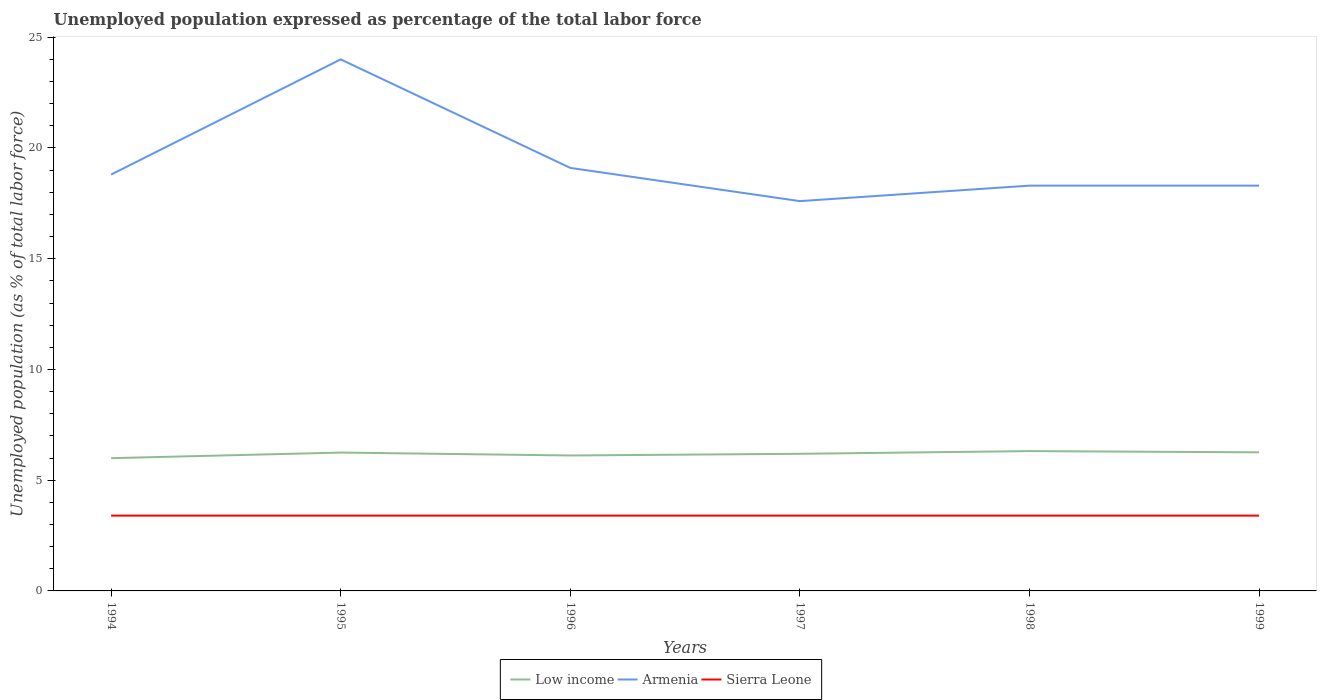Across all years, what is the maximum unemployment in in Low income?
Ensure brevity in your answer.  5.99. What is the difference between the highest and the lowest unemployment in in Armenia?
Provide a succinct answer. 1. How many years are there in the graph?
Provide a succinct answer. 6. Are the values on the major ticks of Y-axis written in scientific E-notation?
Your response must be concise. No. Does the graph contain grids?
Keep it short and to the point. No. Where does the legend appear in the graph?
Provide a short and direct response. Bottom center. How many legend labels are there?
Your answer should be very brief. 3. How are the legend labels stacked?
Offer a terse response. Horizontal. What is the title of the graph?
Offer a terse response. Unemployed population expressed as percentage of the total labor force. What is the label or title of the X-axis?
Provide a succinct answer. Years. What is the label or title of the Y-axis?
Your answer should be compact. Unemployed population (as % of total labor force). What is the Unemployed population (as % of total labor force) of Low income in 1994?
Make the answer very short. 5.99. What is the Unemployed population (as % of total labor force) in Armenia in 1994?
Provide a succinct answer. 18.8. What is the Unemployed population (as % of total labor force) of Sierra Leone in 1994?
Keep it short and to the point. 3.4. What is the Unemployed population (as % of total labor force) in Low income in 1995?
Make the answer very short. 6.25. What is the Unemployed population (as % of total labor force) of Armenia in 1995?
Your answer should be compact. 24. What is the Unemployed population (as % of total labor force) in Sierra Leone in 1995?
Provide a short and direct response. 3.4. What is the Unemployed population (as % of total labor force) of Low income in 1996?
Provide a short and direct response. 6.12. What is the Unemployed population (as % of total labor force) of Armenia in 1996?
Keep it short and to the point. 19.1. What is the Unemployed population (as % of total labor force) in Sierra Leone in 1996?
Ensure brevity in your answer.  3.4. What is the Unemployed population (as % of total labor force) in Low income in 1997?
Your answer should be compact. 6.19. What is the Unemployed population (as % of total labor force) of Armenia in 1997?
Make the answer very short. 17.6. What is the Unemployed population (as % of total labor force) of Sierra Leone in 1997?
Your answer should be very brief. 3.4. What is the Unemployed population (as % of total labor force) in Low income in 1998?
Offer a very short reply. 6.31. What is the Unemployed population (as % of total labor force) of Armenia in 1998?
Ensure brevity in your answer.  18.3. What is the Unemployed population (as % of total labor force) in Sierra Leone in 1998?
Make the answer very short. 3.4. What is the Unemployed population (as % of total labor force) of Low income in 1999?
Offer a terse response. 6.26. What is the Unemployed population (as % of total labor force) in Armenia in 1999?
Your answer should be compact. 18.3. What is the Unemployed population (as % of total labor force) in Sierra Leone in 1999?
Your answer should be very brief. 3.4. Across all years, what is the maximum Unemployed population (as % of total labor force) of Low income?
Make the answer very short. 6.31. Across all years, what is the maximum Unemployed population (as % of total labor force) of Armenia?
Offer a very short reply. 24. Across all years, what is the maximum Unemployed population (as % of total labor force) in Sierra Leone?
Your answer should be very brief. 3.4. Across all years, what is the minimum Unemployed population (as % of total labor force) of Low income?
Offer a terse response. 5.99. Across all years, what is the minimum Unemployed population (as % of total labor force) in Armenia?
Provide a succinct answer. 17.6. Across all years, what is the minimum Unemployed population (as % of total labor force) in Sierra Leone?
Ensure brevity in your answer.  3.4. What is the total Unemployed population (as % of total labor force) in Low income in the graph?
Offer a very short reply. 37.12. What is the total Unemployed population (as % of total labor force) in Armenia in the graph?
Keep it short and to the point. 116.1. What is the total Unemployed population (as % of total labor force) in Sierra Leone in the graph?
Provide a succinct answer. 20.4. What is the difference between the Unemployed population (as % of total labor force) of Low income in 1994 and that in 1995?
Keep it short and to the point. -0.25. What is the difference between the Unemployed population (as % of total labor force) in Low income in 1994 and that in 1996?
Provide a short and direct response. -0.12. What is the difference between the Unemployed population (as % of total labor force) in Low income in 1994 and that in 1997?
Offer a very short reply. -0.2. What is the difference between the Unemployed population (as % of total labor force) in Armenia in 1994 and that in 1997?
Give a very brief answer. 1.2. What is the difference between the Unemployed population (as % of total labor force) of Low income in 1994 and that in 1998?
Keep it short and to the point. -0.32. What is the difference between the Unemployed population (as % of total labor force) of Armenia in 1994 and that in 1998?
Give a very brief answer. 0.5. What is the difference between the Unemployed population (as % of total labor force) in Low income in 1994 and that in 1999?
Your response must be concise. -0.26. What is the difference between the Unemployed population (as % of total labor force) of Sierra Leone in 1994 and that in 1999?
Your answer should be compact. 0. What is the difference between the Unemployed population (as % of total labor force) of Low income in 1995 and that in 1996?
Ensure brevity in your answer.  0.13. What is the difference between the Unemployed population (as % of total labor force) of Low income in 1995 and that in 1997?
Ensure brevity in your answer.  0.06. What is the difference between the Unemployed population (as % of total labor force) in Low income in 1995 and that in 1998?
Provide a short and direct response. -0.07. What is the difference between the Unemployed population (as % of total labor force) in Sierra Leone in 1995 and that in 1998?
Give a very brief answer. 0. What is the difference between the Unemployed population (as % of total labor force) in Low income in 1995 and that in 1999?
Your response must be concise. -0.01. What is the difference between the Unemployed population (as % of total labor force) in Sierra Leone in 1995 and that in 1999?
Your answer should be very brief. 0. What is the difference between the Unemployed population (as % of total labor force) in Low income in 1996 and that in 1997?
Make the answer very short. -0.08. What is the difference between the Unemployed population (as % of total labor force) of Sierra Leone in 1996 and that in 1997?
Make the answer very short. 0. What is the difference between the Unemployed population (as % of total labor force) of Low income in 1996 and that in 1998?
Give a very brief answer. -0.2. What is the difference between the Unemployed population (as % of total labor force) in Armenia in 1996 and that in 1998?
Your answer should be compact. 0.8. What is the difference between the Unemployed population (as % of total labor force) of Low income in 1996 and that in 1999?
Give a very brief answer. -0.14. What is the difference between the Unemployed population (as % of total labor force) in Sierra Leone in 1996 and that in 1999?
Provide a short and direct response. 0. What is the difference between the Unemployed population (as % of total labor force) of Low income in 1997 and that in 1998?
Offer a terse response. -0.12. What is the difference between the Unemployed population (as % of total labor force) in Armenia in 1997 and that in 1998?
Your answer should be compact. -0.7. What is the difference between the Unemployed population (as % of total labor force) in Sierra Leone in 1997 and that in 1998?
Provide a short and direct response. 0. What is the difference between the Unemployed population (as % of total labor force) of Low income in 1997 and that in 1999?
Provide a succinct answer. -0.07. What is the difference between the Unemployed population (as % of total labor force) of Armenia in 1997 and that in 1999?
Provide a succinct answer. -0.7. What is the difference between the Unemployed population (as % of total labor force) of Low income in 1998 and that in 1999?
Offer a terse response. 0.06. What is the difference between the Unemployed population (as % of total labor force) in Low income in 1994 and the Unemployed population (as % of total labor force) in Armenia in 1995?
Offer a very short reply. -18.01. What is the difference between the Unemployed population (as % of total labor force) in Low income in 1994 and the Unemployed population (as % of total labor force) in Sierra Leone in 1995?
Provide a short and direct response. 2.59. What is the difference between the Unemployed population (as % of total labor force) of Armenia in 1994 and the Unemployed population (as % of total labor force) of Sierra Leone in 1995?
Offer a very short reply. 15.4. What is the difference between the Unemployed population (as % of total labor force) in Low income in 1994 and the Unemployed population (as % of total labor force) in Armenia in 1996?
Ensure brevity in your answer.  -13.11. What is the difference between the Unemployed population (as % of total labor force) of Low income in 1994 and the Unemployed population (as % of total labor force) of Sierra Leone in 1996?
Provide a succinct answer. 2.59. What is the difference between the Unemployed population (as % of total labor force) in Low income in 1994 and the Unemployed population (as % of total labor force) in Armenia in 1997?
Your answer should be compact. -11.61. What is the difference between the Unemployed population (as % of total labor force) of Low income in 1994 and the Unemployed population (as % of total labor force) of Sierra Leone in 1997?
Make the answer very short. 2.59. What is the difference between the Unemployed population (as % of total labor force) of Armenia in 1994 and the Unemployed population (as % of total labor force) of Sierra Leone in 1997?
Offer a very short reply. 15.4. What is the difference between the Unemployed population (as % of total labor force) of Low income in 1994 and the Unemployed population (as % of total labor force) of Armenia in 1998?
Offer a terse response. -12.31. What is the difference between the Unemployed population (as % of total labor force) in Low income in 1994 and the Unemployed population (as % of total labor force) in Sierra Leone in 1998?
Your response must be concise. 2.59. What is the difference between the Unemployed population (as % of total labor force) in Armenia in 1994 and the Unemployed population (as % of total labor force) in Sierra Leone in 1998?
Offer a very short reply. 15.4. What is the difference between the Unemployed population (as % of total labor force) in Low income in 1994 and the Unemployed population (as % of total labor force) in Armenia in 1999?
Your answer should be compact. -12.31. What is the difference between the Unemployed population (as % of total labor force) in Low income in 1994 and the Unemployed population (as % of total labor force) in Sierra Leone in 1999?
Offer a terse response. 2.59. What is the difference between the Unemployed population (as % of total labor force) in Armenia in 1994 and the Unemployed population (as % of total labor force) in Sierra Leone in 1999?
Ensure brevity in your answer.  15.4. What is the difference between the Unemployed population (as % of total labor force) in Low income in 1995 and the Unemployed population (as % of total labor force) in Armenia in 1996?
Offer a very short reply. -12.85. What is the difference between the Unemployed population (as % of total labor force) in Low income in 1995 and the Unemployed population (as % of total labor force) in Sierra Leone in 1996?
Make the answer very short. 2.85. What is the difference between the Unemployed population (as % of total labor force) of Armenia in 1995 and the Unemployed population (as % of total labor force) of Sierra Leone in 1996?
Provide a short and direct response. 20.6. What is the difference between the Unemployed population (as % of total labor force) in Low income in 1995 and the Unemployed population (as % of total labor force) in Armenia in 1997?
Keep it short and to the point. -11.35. What is the difference between the Unemployed population (as % of total labor force) of Low income in 1995 and the Unemployed population (as % of total labor force) of Sierra Leone in 1997?
Provide a succinct answer. 2.85. What is the difference between the Unemployed population (as % of total labor force) in Armenia in 1995 and the Unemployed population (as % of total labor force) in Sierra Leone in 1997?
Offer a very short reply. 20.6. What is the difference between the Unemployed population (as % of total labor force) in Low income in 1995 and the Unemployed population (as % of total labor force) in Armenia in 1998?
Offer a terse response. -12.05. What is the difference between the Unemployed population (as % of total labor force) in Low income in 1995 and the Unemployed population (as % of total labor force) in Sierra Leone in 1998?
Make the answer very short. 2.85. What is the difference between the Unemployed population (as % of total labor force) of Armenia in 1995 and the Unemployed population (as % of total labor force) of Sierra Leone in 1998?
Your response must be concise. 20.6. What is the difference between the Unemployed population (as % of total labor force) in Low income in 1995 and the Unemployed population (as % of total labor force) in Armenia in 1999?
Keep it short and to the point. -12.05. What is the difference between the Unemployed population (as % of total labor force) of Low income in 1995 and the Unemployed population (as % of total labor force) of Sierra Leone in 1999?
Make the answer very short. 2.85. What is the difference between the Unemployed population (as % of total labor force) of Armenia in 1995 and the Unemployed population (as % of total labor force) of Sierra Leone in 1999?
Provide a short and direct response. 20.6. What is the difference between the Unemployed population (as % of total labor force) in Low income in 1996 and the Unemployed population (as % of total labor force) in Armenia in 1997?
Ensure brevity in your answer.  -11.48. What is the difference between the Unemployed population (as % of total labor force) of Low income in 1996 and the Unemployed population (as % of total labor force) of Sierra Leone in 1997?
Make the answer very short. 2.72. What is the difference between the Unemployed population (as % of total labor force) of Low income in 1996 and the Unemployed population (as % of total labor force) of Armenia in 1998?
Offer a very short reply. -12.18. What is the difference between the Unemployed population (as % of total labor force) of Low income in 1996 and the Unemployed population (as % of total labor force) of Sierra Leone in 1998?
Provide a short and direct response. 2.72. What is the difference between the Unemployed population (as % of total labor force) in Low income in 1996 and the Unemployed population (as % of total labor force) in Armenia in 1999?
Offer a very short reply. -12.18. What is the difference between the Unemployed population (as % of total labor force) of Low income in 1996 and the Unemployed population (as % of total labor force) of Sierra Leone in 1999?
Make the answer very short. 2.72. What is the difference between the Unemployed population (as % of total labor force) in Armenia in 1996 and the Unemployed population (as % of total labor force) in Sierra Leone in 1999?
Your response must be concise. 15.7. What is the difference between the Unemployed population (as % of total labor force) of Low income in 1997 and the Unemployed population (as % of total labor force) of Armenia in 1998?
Offer a terse response. -12.11. What is the difference between the Unemployed population (as % of total labor force) of Low income in 1997 and the Unemployed population (as % of total labor force) of Sierra Leone in 1998?
Give a very brief answer. 2.79. What is the difference between the Unemployed population (as % of total labor force) in Armenia in 1997 and the Unemployed population (as % of total labor force) in Sierra Leone in 1998?
Ensure brevity in your answer.  14.2. What is the difference between the Unemployed population (as % of total labor force) of Low income in 1997 and the Unemployed population (as % of total labor force) of Armenia in 1999?
Your answer should be compact. -12.11. What is the difference between the Unemployed population (as % of total labor force) in Low income in 1997 and the Unemployed population (as % of total labor force) in Sierra Leone in 1999?
Provide a succinct answer. 2.79. What is the difference between the Unemployed population (as % of total labor force) in Armenia in 1997 and the Unemployed population (as % of total labor force) in Sierra Leone in 1999?
Keep it short and to the point. 14.2. What is the difference between the Unemployed population (as % of total labor force) in Low income in 1998 and the Unemployed population (as % of total labor force) in Armenia in 1999?
Offer a very short reply. -11.99. What is the difference between the Unemployed population (as % of total labor force) of Low income in 1998 and the Unemployed population (as % of total labor force) of Sierra Leone in 1999?
Provide a succinct answer. 2.91. What is the difference between the Unemployed population (as % of total labor force) of Armenia in 1998 and the Unemployed population (as % of total labor force) of Sierra Leone in 1999?
Offer a terse response. 14.9. What is the average Unemployed population (as % of total labor force) in Low income per year?
Offer a very short reply. 6.19. What is the average Unemployed population (as % of total labor force) in Armenia per year?
Keep it short and to the point. 19.35. What is the average Unemployed population (as % of total labor force) of Sierra Leone per year?
Provide a short and direct response. 3.4. In the year 1994, what is the difference between the Unemployed population (as % of total labor force) in Low income and Unemployed population (as % of total labor force) in Armenia?
Your response must be concise. -12.81. In the year 1994, what is the difference between the Unemployed population (as % of total labor force) of Low income and Unemployed population (as % of total labor force) of Sierra Leone?
Your response must be concise. 2.59. In the year 1995, what is the difference between the Unemployed population (as % of total labor force) in Low income and Unemployed population (as % of total labor force) in Armenia?
Keep it short and to the point. -17.75. In the year 1995, what is the difference between the Unemployed population (as % of total labor force) in Low income and Unemployed population (as % of total labor force) in Sierra Leone?
Offer a very short reply. 2.85. In the year 1995, what is the difference between the Unemployed population (as % of total labor force) in Armenia and Unemployed population (as % of total labor force) in Sierra Leone?
Your answer should be very brief. 20.6. In the year 1996, what is the difference between the Unemployed population (as % of total labor force) of Low income and Unemployed population (as % of total labor force) of Armenia?
Keep it short and to the point. -12.98. In the year 1996, what is the difference between the Unemployed population (as % of total labor force) of Low income and Unemployed population (as % of total labor force) of Sierra Leone?
Offer a terse response. 2.72. In the year 1997, what is the difference between the Unemployed population (as % of total labor force) in Low income and Unemployed population (as % of total labor force) in Armenia?
Keep it short and to the point. -11.41. In the year 1997, what is the difference between the Unemployed population (as % of total labor force) of Low income and Unemployed population (as % of total labor force) of Sierra Leone?
Ensure brevity in your answer.  2.79. In the year 1997, what is the difference between the Unemployed population (as % of total labor force) in Armenia and Unemployed population (as % of total labor force) in Sierra Leone?
Ensure brevity in your answer.  14.2. In the year 1998, what is the difference between the Unemployed population (as % of total labor force) of Low income and Unemployed population (as % of total labor force) of Armenia?
Your answer should be compact. -11.99. In the year 1998, what is the difference between the Unemployed population (as % of total labor force) of Low income and Unemployed population (as % of total labor force) of Sierra Leone?
Your answer should be compact. 2.91. In the year 1998, what is the difference between the Unemployed population (as % of total labor force) of Armenia and Unemployed population (as % of total labor force) of Sierra Leone?
Your answer should be compact. 14.9. In the year 1999, what is the difference between the Unemployed population (as % of total labor force) of Low income and Unemployed population (as % of total labor force) of Armenia?
Your response must be concise. -12.04. In the year 1999, what is the difference between the Unemployed population (as % of total labor force) in Low income and Unemployed population (as % of total labor force) in Sierra Leone?
Your answer should be very brief. 2.86. In the year 1999, what is the difference between the Unemployed population (as % of total labor force) of Armenia and Unemployed population (as % of total labor force) of Sierra Leone?
Your response must be concise. 14.9. What is the ratio of the Unemployed population (as % of total labor force) in Low income in 1994 to that in 1995?
Keep it short and to the point. 0.96. What is the ratio of the Unemployed population (as % of total labor force) of Armenia in 1994 to that in 1995?
Give a very brief answer. 0.78. What is the ratio of the Unemployed population (as % of total labor force) in Sierra Leone in 1994 to that in 1995?
Your response must be concise. 1. What is the ratio of the Unemployed population (as % of total labor force) of Low income in 1994 to that in 1996?
Ensure brevity in your answer.  0.98. What is the ratio of the Unemployed population (as % of total labor force) of Armenia in 1994 to that in 1996?
Keep it short and to the point. 0.98. What is the ratio of the Unemployed population (as % of total labor force) of Low income in 1994 to that in 1997?
Provide a succinct answer. 0.97. What is the ratio of the Unemployed population (as % of total labor force) of Armenia in 1994 to that in 1997?
Offer a terse response. 1.07. What is the ratio of the Unemployed population (as % of total labor force) in Low income in 1994 to that in 1998?
Provide a succinct answer. 0.95. What is the ratio of the Unemployed population (as % of total labor force) in Armenia in 1994 to that in 1998?
Offer a very short reply. 1.03. What is the ratio of the Unemployed population (as % of total labor force) in Sierra Leone in 1994 to that in 1998?
Your answer should be very brief. 1. What is the ratio of the Unemployed population (as % of total labor force) of Low income in 1994 to that in 1999?
Give a very brief answer. 0.96. What is the ratio of the Unemployed population (as % of total labor force) in Armenia in 1994 to that in 1999?
Your answer should be compact. 1.03. What is the ratio of the Unemployed population (as % of total labor force) in Sierra Leone in 1994 to that in 1999?
Provide a short and direct response. 1. What is the ratio of the Unemployed population (as % of total labor force) in Low income in 1995 to that in 1996?
Ensure brevity in your answer.  1.02. What is the ratio of the Unemployed population (as % of total labor force) of Armenia in 1995 to that in 1996?
Ensure brevity in your answer.  1.26. What is the ratio of the Unemployed population (as % of total labor force) of Sierra Leone in 1995 to that in 1996?
Provide a short and direct response. 1. What is the ratio of the Unemployed population (as % of total labor force) in Low income in 1995 to that in 1997?
Keep it short and to the point. 1.01. What is the ratio of the Unemployed population (as % of total labor force) in Armenia in 1995 to that in 1997?
Offer a terse response. 1.36. What is the ratio of the Unemployed population (as % of total labor force) in Armenia in 1995 to that in 1998?
Offer a very short reply. 1.31. What is the ratio of the Unemployed population (as % of total labor force) of Low income in 1995 to that in 1999?
Your response must be concise. 1. What is the ratio of the Unemployed population (as % of total labor force) of Armenia in 1995 to that in 1999?
Make the answer very short. 1.31. What is the ratio of the Unemployed population (as % of total labor force) of Low income in 1996 to that in 1997?
Offer a terse response. 0.99. What is the ratio of the Unemployed population (as % of total labor force) of Armenia in 1996 to that in 1997?
Your answer should be compact. 1.09. What is the ratio of the Unemployed population (as % of total labor force) in Low income in 1996 to that in 1998?
Give a very brief answer. 0.97. What is the ratio of the Unemployed population (as % of total labor force) of Armenia in 1996 to that in 1998?
Your answer should be compact. 1.04. What is the ratio of the Unemployed population (as % of total labor force) in Low income in 1996 to that in 1999?
Keep it short and to the point. 0.98. What is the ratio of the Unemployed population (as % of total labor force) of Armenia in 1996 to that in 1999?
Your answer should be very brief. 1.04. What is the ratio of the Unemployed population (as % of total labor force) of Low income in 1997 to that in 1998?
Provide a succinct answer. 0.98. What is the ratio of the Unemployed population (as % of total labor force) in Armenia in 1997 to that in 1998?
Offer a terse response. 0.96. What is the ratio of the Unemployed population (as % of total labor force) of Armenia in 1997 to that in 1999?
Provide a succinct answer. 0.96. What is the ratio of the Unemployed population (as % of total labor force) in Sierra Leone in 1997 to that in 1999?
Ensure brevity in your answer.  1. What is the ratio of the Unemployed population (as % of total labor force) of Low income in 1998 to that in 1999?
Ensure brevity in your answer.  1.01. What is the difference between the highest and the second highest Unemployed population (as % of total labor force) of Low income?
Ensure brevity in your answer.  0.06. What is the difference between the highest and the second highest Unemployed population (as % of total labor force) of Sierra Leone?
Offer a very short reply. 0. What is the difference between the highest and the lowest Unemployed population (as % of total labor force) in Low income?
Provide a succinct answer. 0.32. 